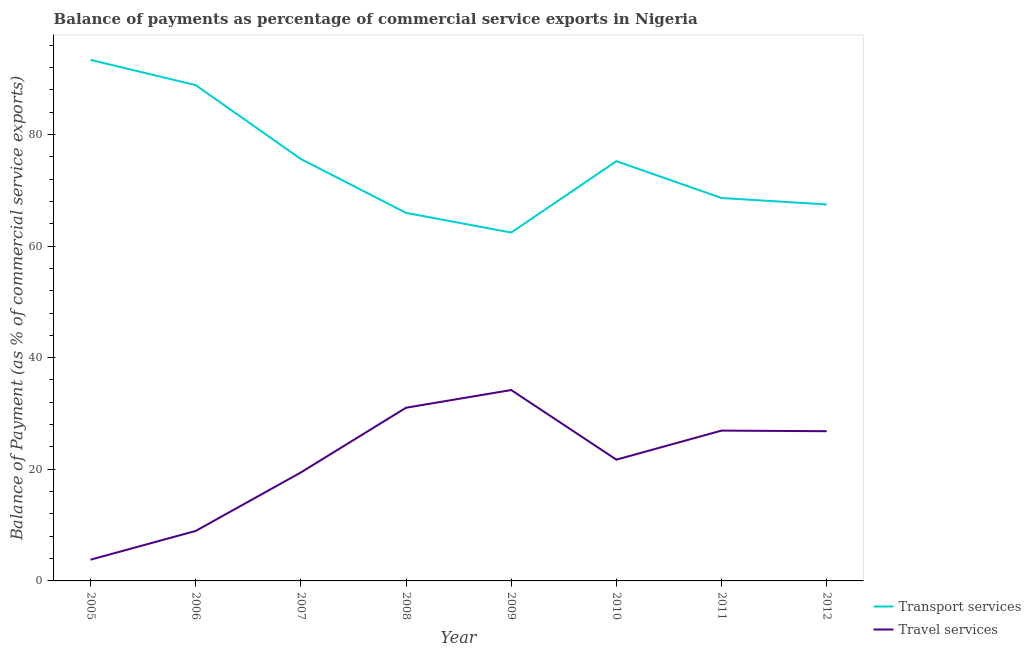How many different coloured lines are there?
Ensure brevity in your answer.  2. Does the line corresponding to balance of payments of travel services intersect with the line corresponding to balance of payments of transport services?
Ensure brevity in your answer.  No. What is the balance of payments of travel services in 2008?
Your response must be concise. 31.03. Across all years, what is the maximum balance of payments of transport services?
Your response must be concise. 93.35. Across all years, what is the minimum balance of payments of travel services?
Keep it short and to the point. 3.8. In which year was the balance of payments of transport services minimum?
Your response must be concise. 2009. What is the total balance of payments of travel services in the graph?
Give a very brief answer. 172.9. What is the difference between the balance of payments of travel services in 2010 and that in 2012?
Make the answer very short. -5.1. What is the difference between the balance of payments of travel services in 2006 and the balance of payments of transport services in 2008?
Provide a short and direct response. -56.99. What is the average balance of payments of travel services per year?
Offer a very short reply. 21.61. In the year 2008, what is the difference between the balance of payments of travel services and balance of payments of transport services?
Make the answer very short. -34.91. In how many years, is the balance of payments of travel services greater than 56 %?
Your response must be concise. 0. What is the ratio of the balance of payments of travel services in 2008 to that in 2010?
Your response must be concise. 1.43. Is the difference between the balance of payments of travel services in 2009 and 2010 greater than the difference between the balance of payments of transport services in 2009 and 2010?
Offer a terse response. Yes. What is the difference between the highest and the second highest balance of payments of transport services?
Your answer should be very brief. 4.53. What is the difference between the highest and the lowest balance of payments of travel services?
Make the answer very short. 30.4. Is the sum of the balance of payments of travel services in 2005 and 2011 greater than the maximum balance of payments of transport services across all years?
Make the answer very short. No. Is the balance of payments of travel services strictly greater than the balance of payments of transport services over the years?
Give a very brief answer. No. How many years are there in the graph?
Keep it short and to the point. 8. What is the difference between two consecutive major ticks on the Y-axis?
Give a very brief answer. 20. Where does the legend appear in the graph?
Provide a short and direct response. Bottom right. How many legend labels are there?
Provide a short and direct response. 2. What is the title of the graph?
Make the answer very short. Balance of payments as percentage of commercial service exports in Nigeria. What is the label or title of the X-axis?
Offer a very short reply. Year. What is the label or title of the Y-axis?
Give a very brief answer. Balance of Payment (as % of commercial service exports). What is the Balance of Payment (as % of commercial service exports) of Transport services in 2005?
Keep it short and to the point. 93.35. What is the Balance of Payment (as % of commercial service exports) of Travel services in 2005?
Offer a terse response. 3.8. What is the Balance of Payment (as % of commercial service exports) of Transport services in 2006?
Offer a very short reply. 88.82. What is the Balance of Payment (as % of commercial service exports) in Travel services in 2006?
Provide a short and direct response. 8.96. What is the Balance of Payment (as % of commercial service exports) in Transport services in 2007?
Keep it short and to the point. 75.59. What is the Balance of Payment (as % of commercial service exports) of Travel services in 2007?
Give a very brief answer. 19.44. What is the Balance of Payment (as % of commercial service exports) in Transport services in 2008?
Offer a very short reply. 65.94. What is the Balance of Payment (as % of commercial service exports) in Travel services in 2008?
Your answer should be very brief. 31.03. What is the Balance of Payment (as % of commercial service exports) in Transport services in 2009?
Your answer should be compact. 62.41. What is the Balance of Payment (as % of commercial service exports) in Travel services in 2009?
Your answer should be very brief. 34.2. What is the Balance of Payment (as % of commercial service exports) in Transport services in 2010?
Ensure brevity in your answer.  75.2. What is the Balance of Payment (as % of commercial service exports) of Travel services in 2010?
Make the answer very short. 21.73. What is the Balance of Payment (as % of commercial service exports) in Transport services in 2011?
Make the answer very short. 68.6. What is the Balance of Payment (as % of commercial service exports) in Travel services in 2011?
Your answer should be compact. 26.93. What is the Balance of Payment (as % of commercial service exports) of Transport services in 2012?
Ensure brevity in your answer.  67.45. What is the Balance of Payment (as % of commercial service exports) of Travel services in 2012?
Ensure brevity in your answer.  26.82. Across all years, what is the maximum Balance of Payment (as % of commercial service exports) in Transport services?
Provide a short and direct response. 93.35. Across all years, what is the maximum Balance of Payment (as % of commercial service exports) in Travel services?
Give a very brief answer. 34.2. Across all years, what is the minimum Balance of Payment (as % of commercial service exports) in Transport services?
Give a very brief answer. 62.41. Across all years, what is the minimum Balance of Payment (as % of commercial service exports) of Travel services?
Make the answer very short. 3.8. What is the total Balance of Payment (as % of commercial service exports) in Transport services in the graph?
Provide a succinct answer. 597.37. What is the total Balance of Payment (as % of commercial service exports) of Travel services in the graph?
Your answer should be very brief. 172.9. What is the difference between the Balance of Payment (as % of commercial service exports) in Transport services in 2005 and that in 2006?
Provide a succinct answer. 4.53. What is the difference between the Balance of Payment (as % of commercial service exports) of Travel services in 2005 and that in 2006?
Keep it short and to the point. -5.15. What is the difference between the Balance of Payment (as % of commercial service exports) in Transport services in 2005 and that in 2007?
Ensure brevity in your answer.  17.76. What is the difference between the Balance of Payment (as % of commercial service exports) of Travel services in 2005 and that in 2007?
Your answer should be compact. -15.63. What is the difference between the Balance of Payment (as % of commercial service exports) of Transport services in 2005 and that in 2008?
Provide a succinct answer. 27.41. What is the difference between the Balance of Payment (as % of commercial service exports) of Travel services in 2005 and that in 2008?
Offer a very short reply. -27.23. What is the difference between the Balance of Payment (as % of commercial service exports) of Transport services in 2005 and that in 2009?
Your response must be concise. 30.94. What is the difference between the Balance of Payment (as % of commercial service exports) of Travel services in 2005 and that in 2009?
Your answer should be very brief. -30.4. What is the difference between the Balance of Payment (as % of commercial service exports) in Transport services in 2005 and that in 2010?
Give a very brief answer. 18.15. What is the difference between the Balance of Payment (as % of commercial service exports) in Travel services in 2005 and that in 2010?
Your response must be concise. -17.92. What is the difference between the Balance of Payment (as % of commercial service exports) of Transport services in 2005 and that in 2011?
Ensure brevity in your answer.  24.75. What is the difference between the Balance of Payment (as % of commercial service exports) in Travel services in 2005 and that in 2011?
Ensure brevity in your answer.  -23.13. What is the difference between the Balance of Payment (as % of commercial service exports) in Transport services in 2005 and that in 2012?
Offer a very short reply. 25.9. What is the difference between the Balance of Payment (as % of commercial service exports) in Travel services in 2005 and that in 2012?
Make the answer very short. -23.02. What is the difference between the Balance of Payment (as % of commercial service exports) in Transport services in 2006 and that in 2007?
Your answer should be very brief. 13.24. What is the difference between the Balance of Payment (as % of commercial service exports) in Travel services in 2006 and that in 2007?
Give a very brief answer. -10.48. What is the difference between the Balance of Payment (as % of commercial service exports) of Transport services in 2006 and that in 2008?
Your answer should be compact. 22.88. What is the difference between the Balance of Payment (as % of commercial service exports) in Travel services in 2006 and that in 2008?
Give a very brief answer. -22.07. What is the difference between the Balance of Payment (as % of commercial service exports) of Transport services in 2006 and that in 2009?
Make the answer very short. 26.41. What is the difference between the Balance of Payment (as % of commercial service exports) in Travel services in 2006 and that in 2009?
Your answer should be very brief. -25.24. What is the difference between the Balance of Payment (as % of commercial service exports) in Transport services in 2006 and that in 2010?
Your answer should be very brief. 13.62. What is the difference between the Balance of Payment (as % of commercial service exports) in Travel services in 2006 and that in 2010?
Ensure brevity in your answer.  -12.77. What is the difference between the Balance of Payment (as % of commercial service exports) in Transport services in 2006 and that in 2011?
Your answer should be very brief. 20.22. What is the difference between the Balance of Payment (as % of commercial service exports) in Travel services in 2006 and that in 2011?
Your answer should be compact. -17.98. What is the difference between the Balance of Payment (as % of commercial service exports) of Transport services in 2006 and that in 2012?
Keep it short and to the point. 21.38. What is the difference between the Balance of Payment (as % of commercial service exports) of Travel services in 2006 and that in 2012?
Your answer should be compact. -17.87. What is the difference between the Balance of Payment (as % of commercial service exports) of Transport services in 2007 and that in 2008?
Your answer should be very brief. 9.64. What is the difference between the Balance of Payment (as % of commercial service exports) in Travel services in 2007 and that in 2008?
Provide a succinct answer. -11.59. What is the difference between the Balance of Payment (as % of commercial service exports) of Transport services in 2007 and that in 2009?
Your answer should be very brief. 13.18. What is the difference between the Balance of Payment (as % of commercial service exports) of Travel services in 2007 and that in 2009?
Provide a short and direct response. -14.76. What is the difference between the Balance of Payment (as % of commercial service exports) of Transport services in 2007 and that in 2010?
Ensure brevity in your answer.  0.39. What is the difference between the Balance of Payment (as % of commercial service exports) in Travel services in 2007 and that in 2010?
Ensure brevity in your answer.  -2.29. What is the difference between the Balance of Payment (as % of commercial service exports) in Transport services in 2007 and that in 2011?
Your answer should be very brief. 6.99. What is the difference between the Balance of Payment (as % of commercial service exports) in Travel services in 2007 and that in 2011?
Offer a terse response. -7.5. What is the difference between the Balance of Payment (as % of commercial service exports) in Transport services in 2007 and that in 2012?
Keep it short and to the point. 8.14. What is the difference between the Balance of Payment (as % of commercial service exports) in Travel services in 2007 and that in 2012?
Provide a succinct answer. -7.39. What is the difference between the Balance of Payment (as % of commercial service exports) of Transport services in 2008 and that in 2009?
Make the answer very short. 3.53. What is the difference between the Balance of Payment (as % of commercial service exports) of Travel services in 2008 and that in 2009?
Provide a short and direct response. -3.17. What is the difference between the Balance of Payment (as % of commercial service exports) of Transport services in 2008 and that in 2010?
Give a very brief answer. -9.26. What is the difference between the Balance of Payment (as % of commercial service exports) of Travel services in 2008 and that in 2010?
Offer a very short reply. 9.3. What is the difference between the Balance of Payment (as % of commercial service exports) in Transport services in 2008 and that in 2011?
Provide a succinct answer. -2.66. What is the difference between the Balance of Payment (as % of commercial service exports) of Travel services in 2008 and that in 2011?
Provide a short and direct response. 4.1. What is the difference between the Balance of Payment (as % of commercial service exports) in Transport services in 2008 and that in 2012?
Your answer should be very brief. -1.5. What is the difference between the Balance of Payment (as % of commercial service exports) in Travel services in 2008 and that in 2012?
Provide a succinct answer. 4.21. What is the difference between the Balance of Payment (as % of commercial service exports) of Transport services in 2009 and that in 2010?
Your answer should be compact. -12.79. What is the difference between the Balance of Payment (as % of commercial service exports) of Travel services in 2009 and that in 2010?
Offer a terse response. 12.47. What is the difference between the Balance of Payment (as % of commercial service exports) of Transport services in 2009 and that in 2011?
Give a very brief answer. -6.19. What is the difference between the Balance of Payment (as % of commercial service exports) of Travel services in 2009 and that in 2011?
Your answer should be compact. 7.27. What is the difference between the Balance of Payment (as % of commercial service exports) of Transport services in 2009 and that in 2012?
Offer a terse response. -5.04. What is the difference between the Balance of Payment (as % of commercial service exports) in Travel services in 2009 and that in 2012?
Your answer should be compact. 7.37. What is the difference between the Balance of Payment (as % of commercial service exports) of Transport services in 2010 and that in 2011?
Make the answer very short. 6.6. What is the difference between the Balance of Payment (as % of commercial service exports) in Travel services in 2010 and that in 2011?
Provide a succinct answer. -5.21. What is the difference between the Balance of Payment (as % of commercial service exports) in Transport services in 2010 and that in 2012?
Offer a terse response. 7.75. What is the difference between the Balance of Payment (as % of commercial service exports) in Travel services in 2010 and that in 2012?
Your answer should be very brief. -5.1. What is the difference between the Balance of Payment (as % of commercial service exports) of Transport services in 2011 and that in 2012?
Offer a terse response. 1.15. What is the difference between the Balance of Payment (as % of commercial service exports) in Travel services in 2011 and that in 2012?
Offer a terse response. 0.11. What is the difference between the Balance of Payment (as % of commercial service exports) of Transport services in 2005 and the Balance of Payment (as % of commercial service exports) of Travel services in 2006?
Ensure brevity in your answer.  84.4. What is the difference between the Balance of Payment (as % of commercial service exports) of Transport services in 2005 and the Balance of Payment (as % of commercial service exports) of Travel services in 2007?
Ensure brevity in your answer.  73.92. What is the difference between the Balance of Payment (as % of commercial service exports) in Transport services in 2005 and the Balance of Payment (as % of commercial service exports) in Travel services in 2008?
Keep it short and to the point. 62.32. What is the difference between the Balance of Payment (as % of commercial service exports) in Transport services in 2005 and the Balance of Payment (as % of commercial service exports) in Travel services in 2009?
Your answer should be compact. 59.15. What is the difference between the Balance of Payment (as % of commercial service exports) of Transport services in 2005 and the Balance of Payment (as % of commercial service exports) of Travel services in 2010?
Provide a short and direct response. 71.63. What is the difference between the Balance of Payment (as % of commercial service exports) of Transport services in 2005 and the Balance of Payment (as % of commercial service exports) of Travel services in 2011?
Provide a short and direct response. 66.42. What is the difference between the Balance of Payment (as % of commercial service exports) of Transport services in 2005 and the Balance of Payment (as % of commercial service exports) of Travel services in 2012?
Your answer should be compact. 66.53. What is the difference between the Balance of Payment (as % of commercial service exports) in Transport services in 2006 and the Balance of Payment (as % of commercial service exports) in Travel services in 2007?
Ensure brevity in your answer.  69.39. What is the difference between the Balance of Payment (as % of commercial service exports) of Transport services in 2006 and the Balance of Payment (as % of commercial service exports) of Travel services in 2008?
Your answer should be very brief. 57.79. What is the difference between the Balance of Payment (as % of commercial service exports) of Transport services in 2006 and the Balance of Payment (as % of commercial service exports) of Travel services in 2009?
Keep it short and to the point. 54.62. What is the difference between the Balance of Payment (as % of commercial service exports) in Transport services in 2006 and the Balance of Payment (as % of commercial service exports) in Travel services in 2010?
Your response must be concise. 67.1. What is the difference between the Balance of Payment (as % of commercial service exports) in Transport services in 2006 and the Balance of Payment (as % of commercial service exports) in Travel services in 2011?
Keep it short and to the point. 61.89. What is the difference between the Balance of Payment (as % of commercial service exports) of Transport services in 2006 and the Balance of Payment (as % of commercial service exports) of Travel services in 2012?
Give a very brief answer. 62. What is the difference between the Balance of Payment (as % of commercial service exports) of Transport services in 2007 and the Balance of Payment (as % of commercial service exports) of Travel services in 2008?
Offer a very short reply. 44.56. What is the difference between the Balance of Payment (as % of commercial service exports) in Transport services in 2007 and the Balance of Payment (as % of commercial service exports) in Travel services in 2009?
Offer a terse response. 41.39. What is the difference between the Balance of Payment (as % of commercial service exports) of Transport services in 2007 and the Balance of Payment (as % of commercial service exports) of Travel services in 2010?
Give a very brief answer. 53.86. What is the difference between the Balance of Payment (as % of commercial service exports) in Transport services in 2007 and the Balance of Payment (as % of commercial service exports) in Travel services in 2011?
Keep it short and to the point. 48.66. What is the difference between the Balance of Payment (as % of commercial service exports) of Transport services in 2007 and the Balance of Payment (as % of commercial service exports) of Travel services in 2012?
Make the answer very short. 48.76. What is the difference between the Balance of Payment (as % of commercial service exports) in Transport services in 2008 and the Balance of Payment (as % of commercial service exports) in Travel services in 2009?
Keep it short and to the point. 31.74. What is the difference between the Balance of Payment (as % of commercial service exports) of Transport services in 2008 and the Balance of Payment (as % of commercial service exports) of Travel services in 2010?
Ensure brevity in your answer.  44.22. What is the difference between the Balance of Payment (as % of commercial service exports) of Transport services in 2008 and the Balance of Payment (as % of commercial service exports) of Travel services in 2011?
Your answer should be compact. 39.01. What is the difference between the Balance of Payment (as % of commercial service exports) of Transport services in 2008 and the Balance of Payment (as % of commercial service exports) of Travel services in 2012?
Offer a very short reply. 39.12. What is the difference between the Balance of Payment (as % of commercial service exports) of Transport services in 2009 and the Balance of Payment (as % of commercial service exports) of Travel services in 2010?
Your answer should be very brief. 40.69. What is the difference between the Balance of Payment (as % of commercial service exports) in Transport services in 2009 and the Balance of Payment (as % of commercial service exports) in Travel services in 2011?
Give a very brief answer. 35.48. What is the difference between the Balance of Payment (as % of commercial service exports) of Transport services in 2009 and the Balance of Payment (as % of commercial service exports) of Travel services in 2012?
Provide a short and direct response. 35.59. What is the difference between the Balance of Payment (as % of commercial service exports) in Transport services in 2010 and the Balance of Payment (as % of commercial service exports) in Travel services in 2011?
Your answer should be compact. 48.27. What is the difference between the Balance of Payment (as % of commercial service exports) in Transport services in 2010 and the Balance of Payment (as % of commercial service exports) in Travel services in 2012?
Your response must be concise. 48.38. What is the difference between the Balance of Payment (as % of commercial service exports) of Transport services in 2011 and the Balance of Payment (as % of commercial service exports) of Travel services in 2012?
Make the answer very short. 41.78. What is the average Balance of Payment (as % of commercial service exports) in Transport services per year?
Offer a terse response. 74.67. What is the average Balance of Payment (as % of commercial service exports) in Travel services per year?
Your response must be concise. 21.61. In the year 2005, what is the difference between the Balance of Payment (as % of commercial service exports) of Transport services and Balance of Payment (as % of commercial service exports) of Travel services?
Make the answer very short. 89.55. In the year 2006, what is the difference between the Balance of Payment (as % of commercial service exports) of Transport services and Balance of Payment (as % of commercial service exports) of Travel services?
Give a very brief answer. 79.87. In the year 2007, what is the difference between the Balance of Payment (as % of commercial service exports) in Transport services and Balance of Payment (as % of commercial service exports) in Travel services?
Your response must be concise. 56.15. In the year 2008, what is the difference between the Balance of Payment (as % of commercial service exports) in Transport services and Balance of Payment (as % of commercial service exports) in Travel services?
Provide a succinct answer. 34.91. In the year 2009, what is the difference between the Balance of Payment (as % of commercial service exports) of Transport services and Balance of Payment (as % of commercial service exports) of Travel services?
Provide a short and direct response. 28.21. In the year 2010, what is the difference between the Balance of Payment (as % of commercial service exports) in Transport services and Balance of Payment (as % of commercial service exports) in Travel services?
Provide a short and direct response. 53.48. In the year 2011, what is the difference between the Balance of Payment (as % of commercial service exports) in Transport services and Balance of Payment (as % of commercial service exports) in Travel services?
Ensure brevity in your answer.  41.67. In the year 2012, what is the difference between the Balance of Payment (as % of commercial service exports) of Transport services and Balance of Payment (as % of commercial service exports) of Travel services?
Your answer should be compact. 40.62. What is the ratio of the Balance of Payment (as % of commercial service exports) in Transport services in 2005 to that in 2006?
Provide a succinct answer. 1.05. What is the ratio of the Balance of Payment (as % of commercial service exports) in Travel services in 2005 to that in 2006?
Provide a short and direct response. 0.42. What is the ratio of the Balance of Payment (as % of commercial service exports) in Transport services in 2005 to that in 2007?
Ensure brevity in your answer.  1.24. What is the ratio of the Balance of Payment (as % of commercial service exports) in Travel services in 2005 to that in 2007?
Offer a terse response. 0.2. What is the ratio of the Balance of Payment (as % of commercial service exports) of Transport services in 2005 to that in 2008?
Offer a terse response. 1.42. What is the ratio of the Balance of Payment (as % of commercial service exports) of Travel services in 2005 to that in 2008?
Ensure brevity in your answer.  0.12. What is the ratio of the Balance of Payment (as % of commercial service exports) of Transport services in 2005 to that in 2009?
Offer a very short reply. 1.5. What is the ratio of the Balance of Payment (as % of commercial service exports) in Travel services in 2005 to that in 2009?
Provide a short and direct response. 0.11. What is the ratio of the Balance of Payment (as % of commercial service exports) of Transport services in 2005 to that in 2010?
Provide a succinct answer. 1.24. What is the ratio of the Balance of Payment (as % of commercial service exports) of Travel services in 2005 to that in 2010?
Provide a succinct answer. 0.17. What is the ratio of the Balance of Payment (as % of commercial service exports) of Transport services in 2005 to that in 2011?
Offer a terse response. 1.36. What is the ratio of the Balance of Payment (as % of commercial service exports) in Travel services in 2005 to that in 2011?
Offer a terse response. 0.14. What is the ratio of the Balance of Payment (as % of commercial service exports) of Transport services in 2005 to that in 2012?
Ensure brevity in your answer.  1.38. What is the ratio of the Balance of Payment (as % of commercial service exports) of Travel services in 2005 to that in 2012?
Keep it short and to the point. 0.14. What is the ratio of the Balance of Payment (as % of commercial service exports) in Transport services in 2006 to that in 2007?
Provide a succinct answer. 1.18. What is the ratio of the Balance of Payment (as % of commercial service exports) in Travel services in 2006 to that in 2007?
Your answer should be compact. 0.46. What is the ratio of the Balance of Payment (as % of commercial service exports) of Transport services in 2006 to that in 2008?
Offer a terse response. 1.35. What is the ratio of the Balance of Payment (as % of commercial service exports) of Travel services in 2006 to that in 2008?
Your answer should be compact. 0.29. What is the ratio of the Balance of Payment (as % of commercial service exports) of Transport services in 2006 to that in 2009?
Offer a very short reply. 1.42. What is the ratio of the Balance of Payment (as % of commercial service exports) of Travel services in 2006 to that in 2009?
Provide a short and direct response. 0.26. What is the ratio of the Balance of Payment (as % of commercial service exports) of Transport services in 2006 to that in 2010?
Offer a very short reply. 1.18. What is the ratio of the Balance of Payment (as % of commercial service exports) in Travel services in 2006 to that in 2010?
Make the answer very short. 0.41. What is the ratio of the Balance of Payment (as % of commercial service exports) in Transport services in 2006 to that in 2011?
Offer a very short reply. 1.29. What is the ratio of the Balance of Payment (as % of commercial service exports) of Travel services in 2006 to that in 2011?
Offer a terse response. 0.33. What is the ratio of the Balance of Payment (as % of commercial service exports) in Transport services in 2006 to that in 2012?
Give a very brief answer. 1.32. What is the ratio of the Balance of Payment (as % of commercial service exports) in Travel services in 2006 to that in 2012?
Offer a very short reply. 0.33. What is the ratio of the Balance of Payment (as % of commercial service exports) of Transport services in 2007 to that in 2008?
Your response must be concise. 1.15. What is the ratio of the Balance of Payment (as % of commercial service exports) in Travel services in 2007 to that in 2008?
Ensure brevity in your answer.  0.63. What is the ratio of the Balance of Payment (as % of commercial service exports) in Transport services in 2007 to that in 2009?
Your answer should be compact. 1.21. What is the ratio of the Balance of Payment (as % of commercial service exports) in Travel services in 2007 to that in 2009?
Make the answer very short. 0.57. What is the ratio of the Balance of Payment (as % of commercial service exports) in Transport services in 2007 to that in 2010?
Give a very brief answer. 1.01. What is the ratio of the Balance of Payment (as % of commercial service exports) of Travel services in 2007 to that in 2010?
Make the answer very short. 0.89. What is the ratio of the Balance of Payment (as % of commercial service exports) in Transport services in 2007 to that in 2011?
Your response must be concise. 1.1. What is the ratio of the Balance of Payment (as % of commercial service exports) in Travel services in 2007 to that in 2011?
Your answer should be very brief. 0.72. What is the ratio of the Balance of Payment (as % of commercial service exports) of Transport services in 2007 to that in 2012?
Your answer should be compact. 1.12. What is the ratio of the Balance of Payment (as % of commercial service exports) of Travel services in 2007 to that in 2012?
Offer a very short reply. 0.72. What is the ratio of the Balance of Payment (as % of commercial service exports) in Transport services in 2008 to that in 2009?
Make the answer very short. 1.06. What is the ratio of the Balance of Payment (as % of commercial service exports) of Travel services in 2008 to that in 2009?
Your answer should be very brief. 0.91. What is the ratio of the Balance of Payment (as % of commercial service exports) of Transport services in 2008 to that in 2010?
Give a very brief answer. 0.88. What is the ratio of the Balance of Payment (as % of commercial service exports) in Travel services in 2008 to that in 2010?
Your response must be concise. 1.43. What is the ratio of the Balance of Payment (as % of commercial service exports) of Transport services in 2008 to that in 2011?
Give a very brief answer. 0.96. What is the ratio of the Balance of Payment (as % of commercial service exports) of Travel services in 2008 to that in 2011?
Provide a succinct answer. 1.15. What is the ratio of the Balance of Payment (as % of commercial service exports) in Transport services in 2008 to that in 2012?
Your answer should be compact. 0.98. What is the ratio of the Balance of Payment (as % of commercial service exports) in Travel services in 2008 to that in 2012?
Your response must be concise. 1.16. What is the ratio of the Balance of Payment (as % of commercial service exports) in Transport services in 2009 to that in 2010?
Offer a very short reply. 0.83. What is the ratio of the Balance of Payment (as % of commercial service exports) of Travel services in 2009 to that in 2010?
Give a very brief answer. 1.57. What is the ratio of the Balance of Payment (as % of commercial service exports) of Transport services in 2009 to that in 2011?
Your response must be concise. 0.91. What is the ratio of the Balance of Payment (as % of commercial service exports) of Travel services in 2009 to that in 2011?
Offer a terse response. 1.27. What is the ratio of the Balance of Payment (as % of commercial service exports) in Transport services in 2009 to that in 2012?
Your response must be concise. 0.93. What is the ratio of the Balance of Payment (as % of commercial service exports) of Travel services in 2009 to that in 2012?
Give a very brief answer. 1.27. What is the ratio of the Balance of Payment (as % of commercial service exports) in Transport services in 2010 to that in 2011?
Make the answer very short. 1.1. What is the ratio of the Balance of Payment (as % of commercial service exports) in Travel services in 2010 to that in 2011?
Make the answer very short. 0.81. What is the ratio of the Balance of Payment (as % of commercial service exports) of Transport services in 2010 to that in 2012?
Keep it short and to the point. 1.11. What is the ratio of the Balance of Payment (as % of commercial service exports) of Travel services in 2010 to that in 2012?
Provide a succinct answer. 0.81. What is the ratio of the Balance of Payment (as % of commercial service exports) of Transport services in 2011 to that in 2012?
Your response must be concise. 1.02. What is the ratio of the Balance of Payment (as % of commercial service exports) of Travel services in 2011 to that in 2012?
Provide a short and direct response. 1. What is the difference between the highest and the second highest Balance of Payment (as % of commercial service exports) of Transport services?
Your answer should be very brief. 4.53. What is the difference between the highest and the second highest Balance of Payment (as % of commercial service exports) in Travel services?
Your answer should be very brief. 3.17. What is the difference between the highest and the lowest Balance of Payment (as % of commercial service exports) of Transport services?
Your answer should be very brief. 30.94. What is the difference between the highest and the lowest Balance of Payment (as % of commercial service exports) in Travel services?
Provide a succinct answer. 30.4. 